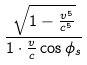<formula> <loc_0><loc_0><loc_500><loc_500>\frac { \sqrt { 1 - \frac { v ^ { 5 } } { c ^ { 5 } } } } { 1 \cdot \frac { v } { c } \cos \phi _ { s } }</formula> 